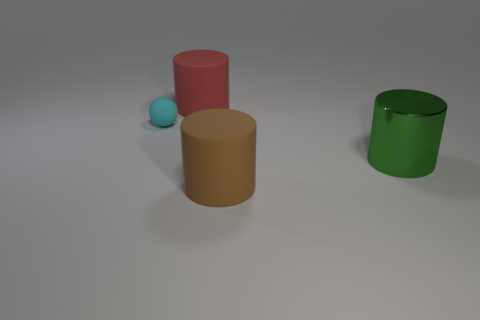Subtract all big brown matte cylinders. How many cylinders are left? 2 Subtract all red cylinders. How many cylinders are left? 2 Add 4 cyan balls. How many objects exist? 8 Subtract all balls. How many objects are left? 3 Add 2 cyan things. How many cyan things are left? 3 Add 3 tiny things. How many tiny things exist? 4 Subtract 0 gray cylinders. How many objects are left? 4 Subtract all cyan cylinders. Subtract all green cubes. How many cylinders are left? 3 Subtract all large brown objects. Subtract all big brown matte cylinders. How many objects are left? 2 